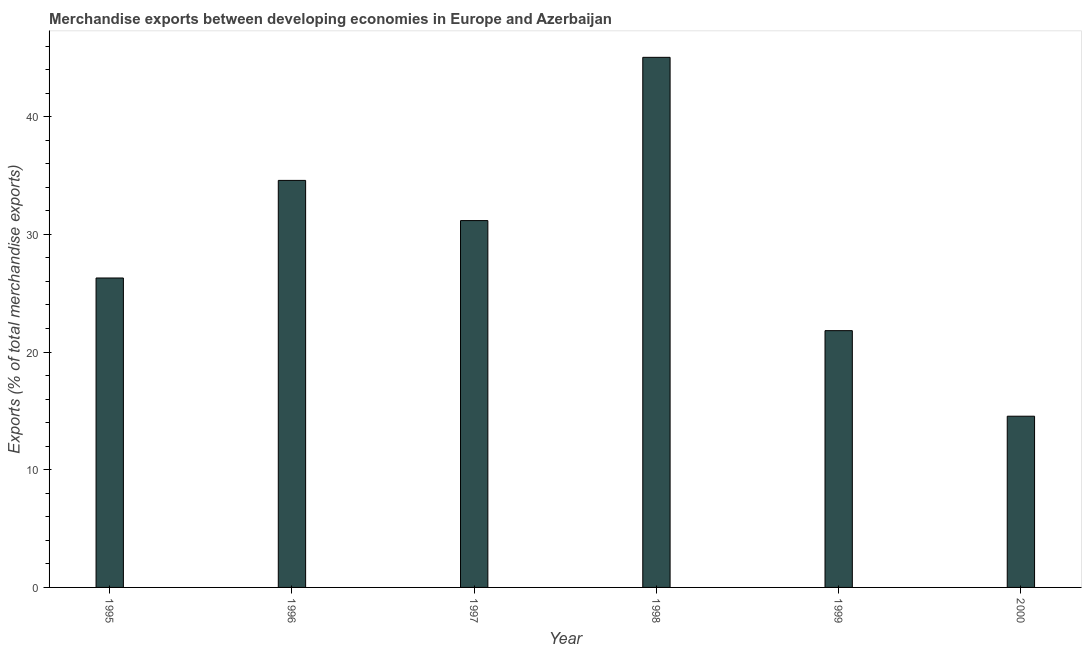Does the graph contain grids?
Provide a short and direct response. No. What is the title of the graph?
Provide a short and direct response. Merchandise exports between developing economies in Europe and Azerbaijan. What is the label or title of the Y-axis?
Your answer should be very brief. Exports (% of total merchandise exports). What is the merchandise exports in 1997?
Make the answer very short. 31.17. Across all years, what is the maximum merchandise exports?
Provide a short and direct response. 45.04. Across all years, what is the minimum merchandise exports?
Make the answer very short. 14.55. In which year was the merchandise exports maximum?
Provide a succinct answer. 1998. What is the sum of the merchandise exports?
Ensure brevity in your answer.  173.46. What is the difference between the merchandise exports in 1995 and 1997?
Your answer should be very brief. -4.88. What is the average merchandise exports per year?
Provide a succinct answer. 28.91. What is the median merchandise exports?
Ensure brevity in your answer.  28.73. What is the ratio of the merchandise exports in 1997 to that in 1999?
Offer a very short reply. 1.43. Is the merchandise exports in 1998 less than that in 1999?
Your response must be concise. No. What is the difference between the highest and the second highest merchandise exports?
Keep it short and to the point. 10.46. What is the difference between the highest and the lowest merchandise exports?
Your answer should be compact. 30.49. In how many years, is the merchandise exports greater than the average merchandise exports taken over all years?
Keep it short and to the point. 3. Are all the bars in the graph horizontal?
Ensure brevity in your answer.  No. What is the difference between two consecutive major ticks on the Y-axis?
Provide a succinct answer. 10. Are the values on the major ticks of Y-axis written in scientific E-notation?
Provide a short and direct response. No. What is the Exports (% of total merchandise exports) of 1995?
Give a very brief answer. 26.29. What is the Exports (% of total merchandise exports) in 1996?
Ensure brevity in your answer.  34.59. What is the Exports (% of total merchandise exports) in 1997?
Offer a terse response. 31.17. What is the Exports (% of total merchandise exports) of 1998?
Your answer should be very brief. 45.04. What is the Exports (% of total merchandise exports) in 1999?
Ensure brevity in your answer.  21.82. What is the Exports (% of total merchandise exports) of 2000?
Offer a very short reply. 14.55. What is the difference between the Exports (% of total merchandise exports) in 1995 and 1996?
Provide a short and direct response. -8.29. What is the difference between the Exports (% of total merchandise exports) in 1995 and 1997?
Your response must be concise. -4.88. What is the difference between the Exports (% of total merchandise exports) in 1995 and 1998?
Make the answer very short. -18.75. What is the difference between the Exports (% of total merchandise exports) in 1995 and 1999?
Offer a very short reply. 4.48. What is the difference between the Exports (% of total merchandise exports) in 1995 and 2000?
Your response must be concise. 11.74. What is the difference between the Exports (% of total merchandise exports) in 1996 and 1997?
Provide a succinct answer. 3.42. What is the difference between the Exports (% of total merchandise exports) in 1996 and 1998?
Offer a terse response. -10.46. What is the difference between the Exports (% of total merchandise exports) in 1996 and 1999?
Offer a very short reply. 12.77. What is the difference between the Exports (% of total merchandise exports) in 1996 and 2000?
Keep it short and to the point. 20.04. What is the difference between the Exports (% of total merchandise exports) in 1997 and 1998?
Your answer should be very brief. -13.87. What is the difference between the Exports (% of total merchandise exports) in 1997 and 1999?
Offer a very short reply. 9.35. What is the difference between the Exports (% of total merchandise exports) in 1997 and 2000?
Make the answer very short. 16.62. What is the difference between the Exports (% of total merchandise exports) in 1998 and 1999?
Your answer should be compact. 23.22. What is the difference between the Exports (% of total merchandise exports) in 1998 and 2000?
Make the answer very short. 30.49. What is the difference between the Exports (% of total merchandise exports) in 1999 and 2000?
Offer a terse response. 7.27. What is the ratio of the Exports (% of total merchandise exports) in 1995 to that in 1996?
Offer a terse response. 0.76. What is the ratio of the Exports (% of total merchandise exports) in 1995 to that in 1997?
Give a very brief answer. 0.84. What is the ratio of the Exports (% of total merchandise exports) in 1995 to that in 1998?
Provide a succinct answer. 0.58. What is the ratio of the Exports (% of total merchandise exports) in 1995 to that in 1999?
Provide a short and direct response. 1.21. What is the ratio of the Exports (% of total merchandise exports) in 1995 to that in 2000?
Offer a terse response. 1.81. What is the ratio of the Exports (% of total merchandise exports) in 1996 to that in 1997?
Your response must be concise. 1.11. What is the ratio of the Exports (% of total merchandise exports) in 1996 to that in 1998?
Provide a short and direct response. 0.77. What is the ratio of the Exports (% of total merchandise exports) in 1996 to that in 1999?
Offer a terse response. 1.58. What is the ratio of the Exports (% of total merchandise exports) in 1996 to that in 2000?
Make the answer very short. 2.38. What is the ratio of the Exports (% of total merchandise exports) in 1997 to that in 1998?
Offer a terse response. 0.69. What is the ratio of the Exports (% of total merchandise exports) in 1997 to that in 1999?
Your response must be concise. 1.43. What is the ratio of the Exports (% of total merchandise exports) in 1997 to that in 2000?
Give a very brief answer. 2.14. What is the ratio of the Exports (% of total merchandise exports) in 1998 to that in 1999?
Make the answer very short. 2.06. What is the ratio of the Exports (% of total merchandise exports) in 1998 to that in 2000?
Provide a short and direct response. 3.1. What is the ratio of the Exports (% of total merchandise exports) in 1999 to that in 2000?
Provide a succinct answer. 1.5. 